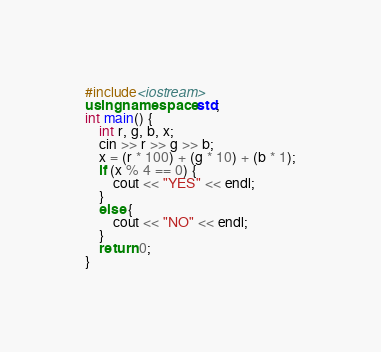Convert code to text. <code><loc_0><loc_0><loc_500><loc_500><_C++_>#include<iostream>
using namespace std;
int main() {
	int r, g, b, x;
	cin >> r >> g >> b;
	x = (r * 100) + (g * 10) + (b * 1);
	if (x % 4 == 0) {
		cout << "YES" << endl;
	}
	else {
		cout << "NO" << endl;
	}
	return 0;
}</code> 